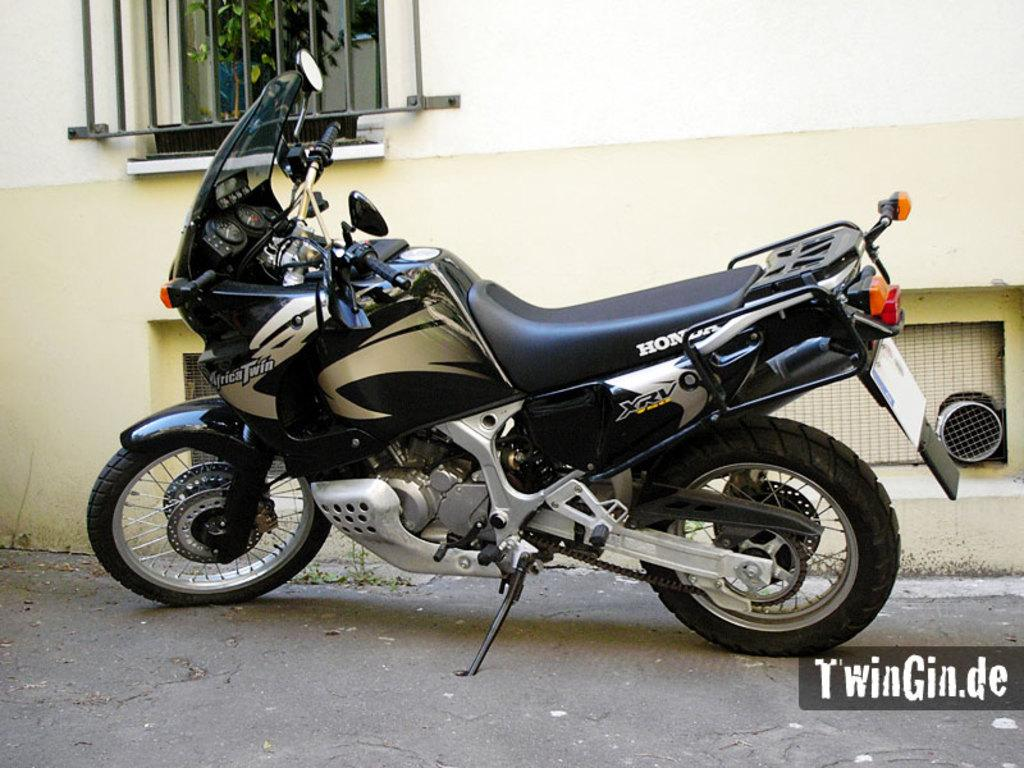What is the main object in the image? There is a bike in the image. How is the bike positioned in the image? The bike is standing on the ground. What architectural feature can be seen in the image? There is a window in the image. Where is the window located in the image? The window is on a wall. How many elbows can be seen on the bike in the image? There are no elbows present on the bike in the image, as it is a non-living object. Who is the creator of the bike in the image? The creator of the bike cannot be determined from the image alone, as it does not provide information about the bike's manufacturer or designer. 